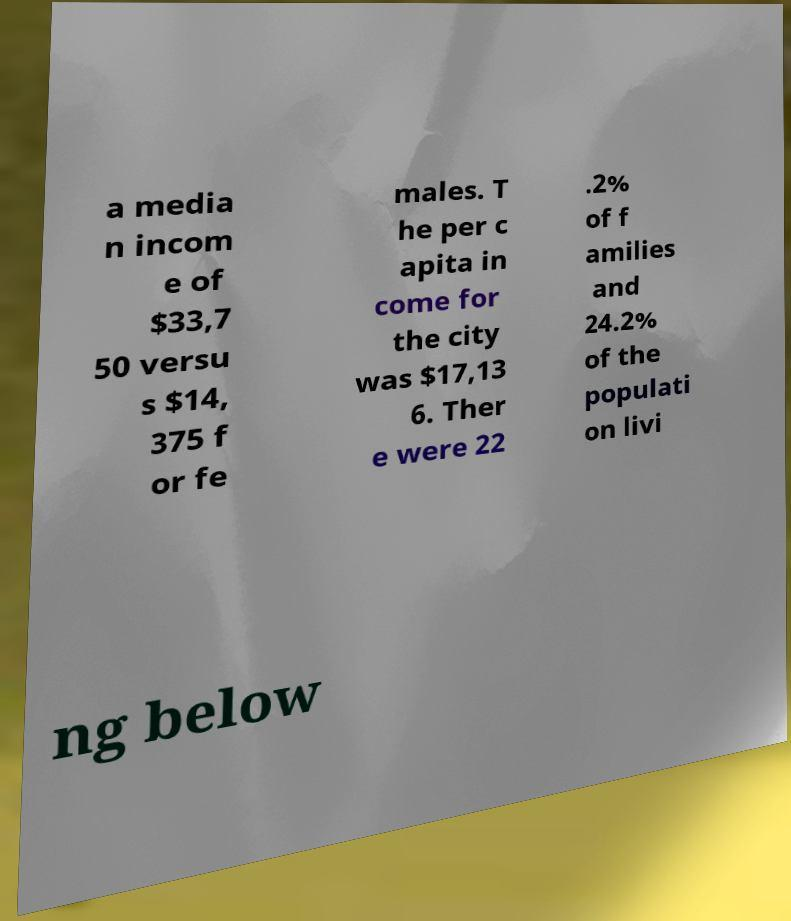Please identify and transcribe the text found in this image. a media n incom e of $33,7 50 versu s $14, 375 f or fe males. T he per c apita in come for the city was $17,13 6. Ther e were 22 .2% of f amilies and 24.2% of the populati on livi ng below 